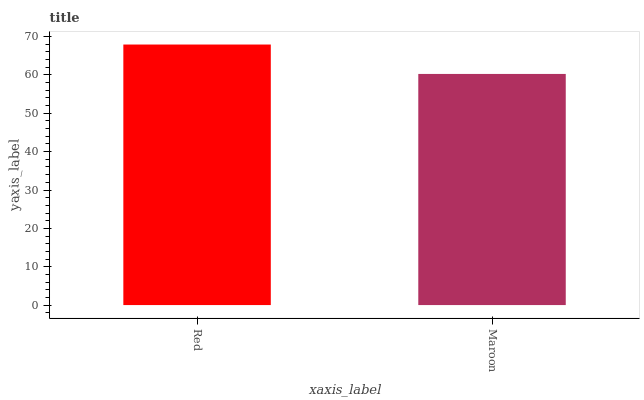Is Maroon the minimum?
Answer yes or no. Yes. Is Red the maximum?
Answer yes or no. Yes. Is Maroon the maximum?
Answer yes or no. No. Is Red greater than Maroon?
Answer yes or no. Yes. Is Maroon less than Red?
Answer yes or no. Yes. Is Maroon greater than Red?
Answer yes or no. No. Is Red less than Maroon?
Answer yes or no. No. Is Red the high median?
Answer yes or no. Yes. Is Maroon the low median?
Answer yes or no. Yes. Is Maroon the high median?
Answer yes or no. No. Is Red the low median?
Answer yes or no. No. 